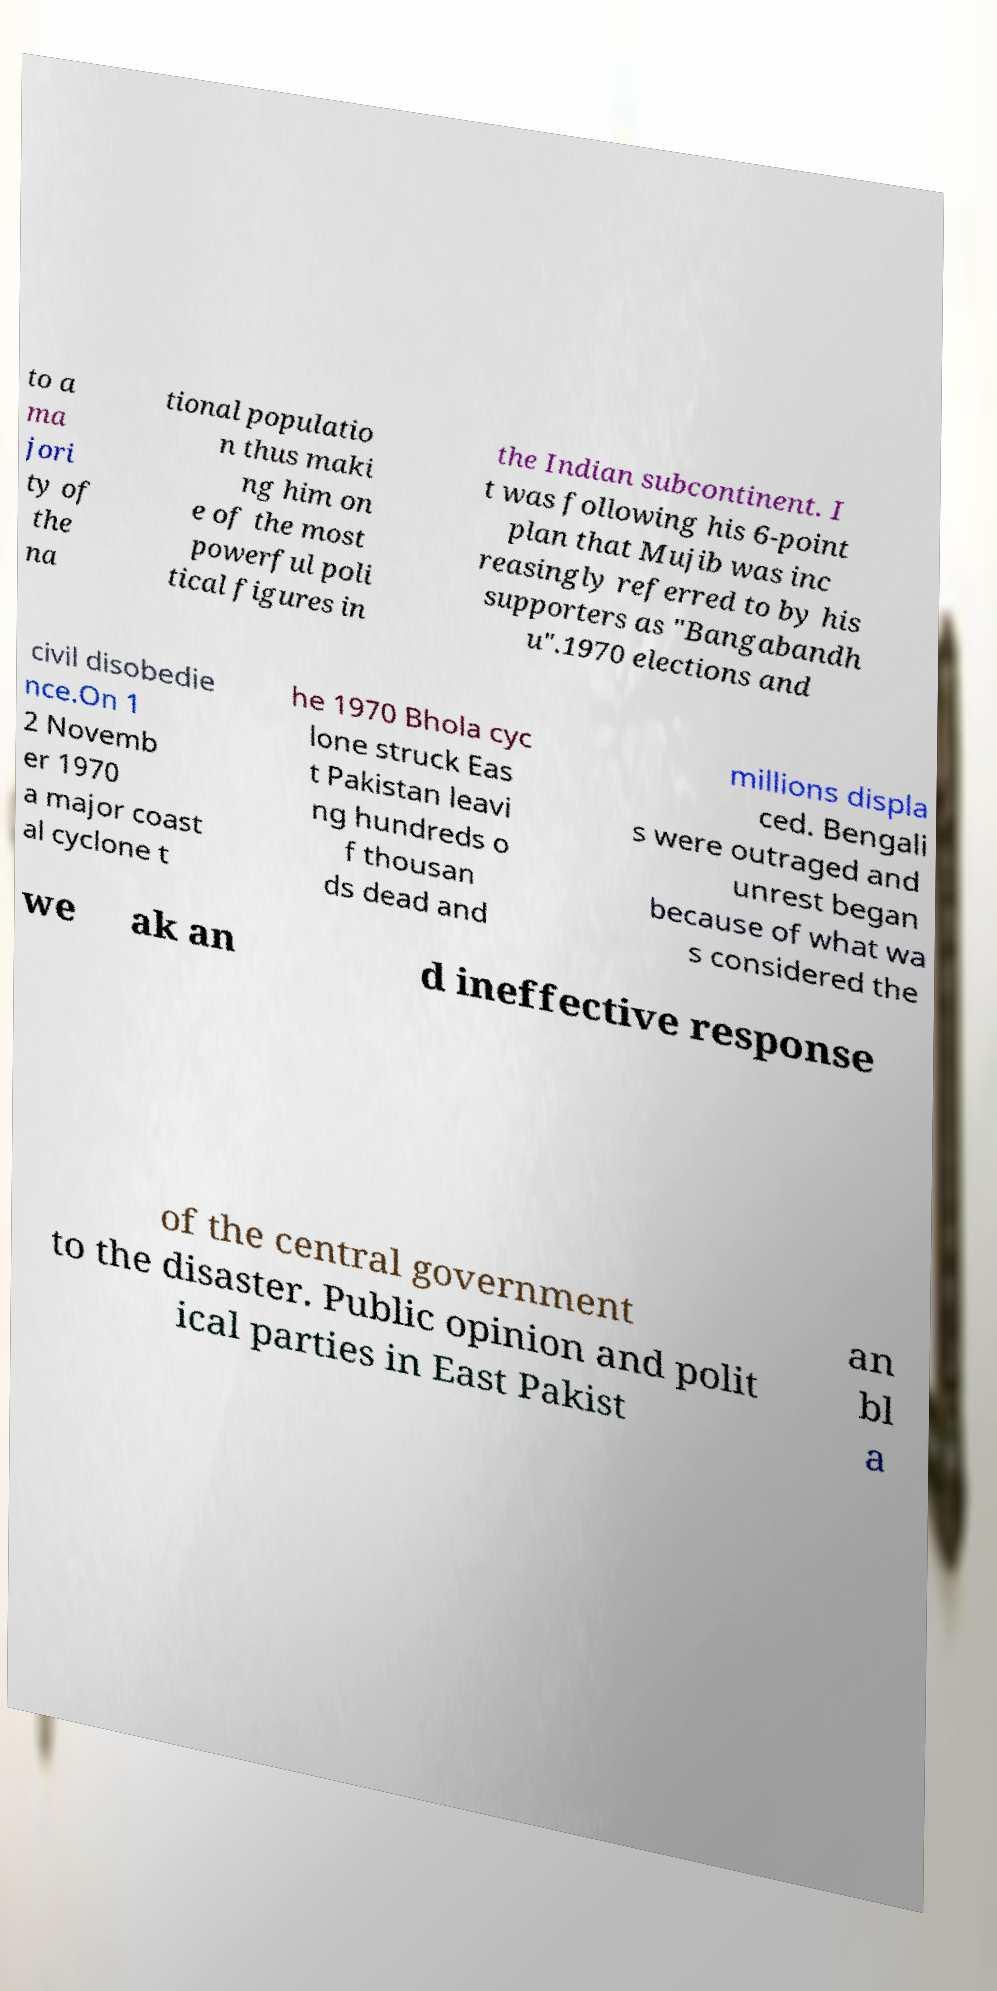Can you accurately transcribe the text from the provided image for me? to a ma jori ty of the na tional populatio n thus maki ng him on e of the most powerful poli tical figures in the Indian subcontinent. I t was following his 6-point plan that Mujib was inc reasingly referred to by his supporters as "Bangabandh u".1970 elections and civil disobedie nce.On 1 2 Novemb er 1970 a major coast al cyclone t he 1970 Bhola cyc lone struck Eas t Pakistan leavi ng hundreds o f thousan ds dead and millions displa ced. Bengali s were outraged and unrest began because of what wa s considered the we ak an d ineffective response of the central government to the disaster. Public opinion and polit ical parties in East Pakist an bl a 